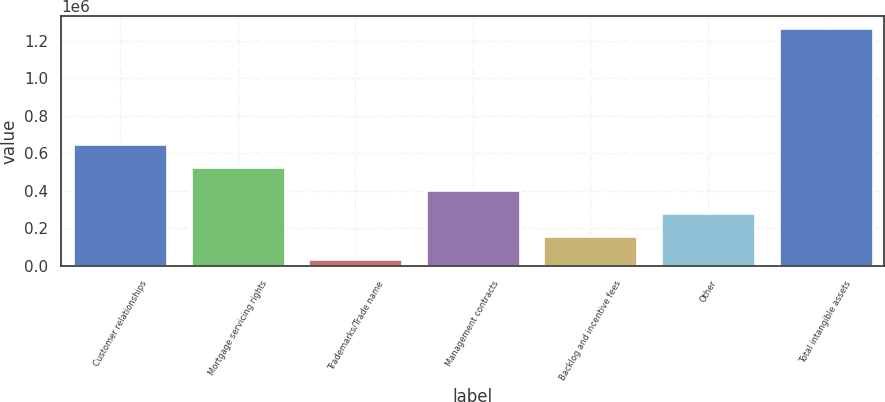Convert chart. <chart><loc_0><loc_0><loc_500><loc_500><bar_chart><fcel>Customer relationships<fcel>Mortgage servicing rights<fcel>Trademarks/Trade name<fcel>Management contracts<fcel>Backlog and incentive fees<fcel>Other<fcel>Total intangible assets<nl><fcel>650754<fcel>527753<fcel>35748<fcel>404752<fcel>158749<fcel>281750<fcel>1.26576e+06<nl></chart> 